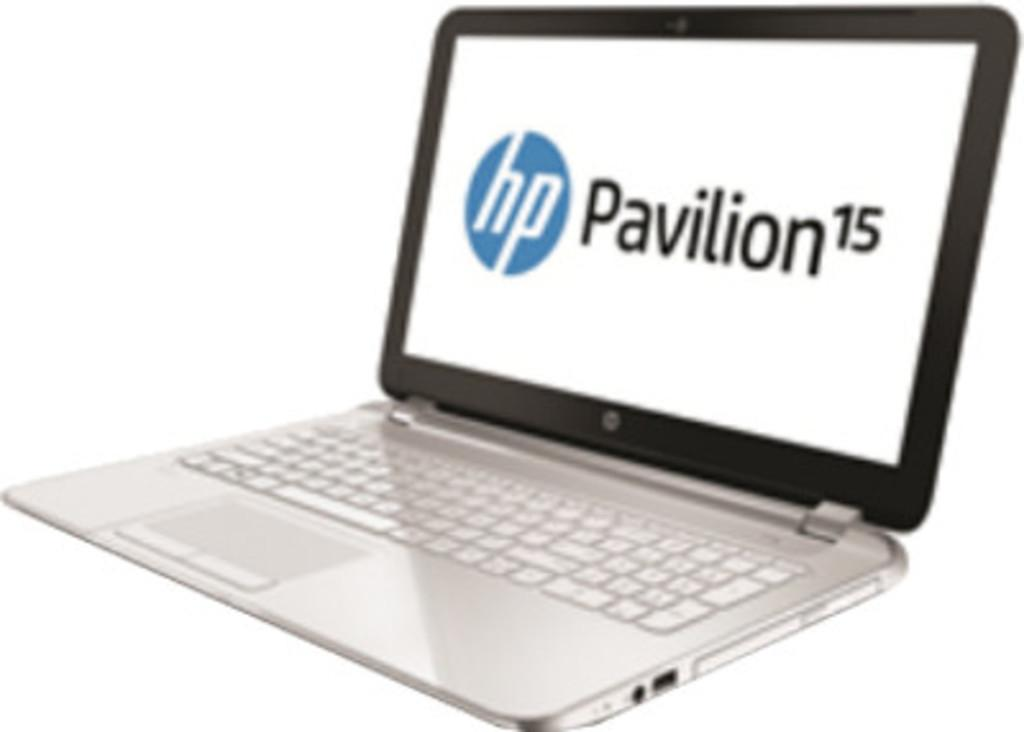<image>
Create a compact narrative representing the image presented. A HP Pavilion laptop sits on a white background. 